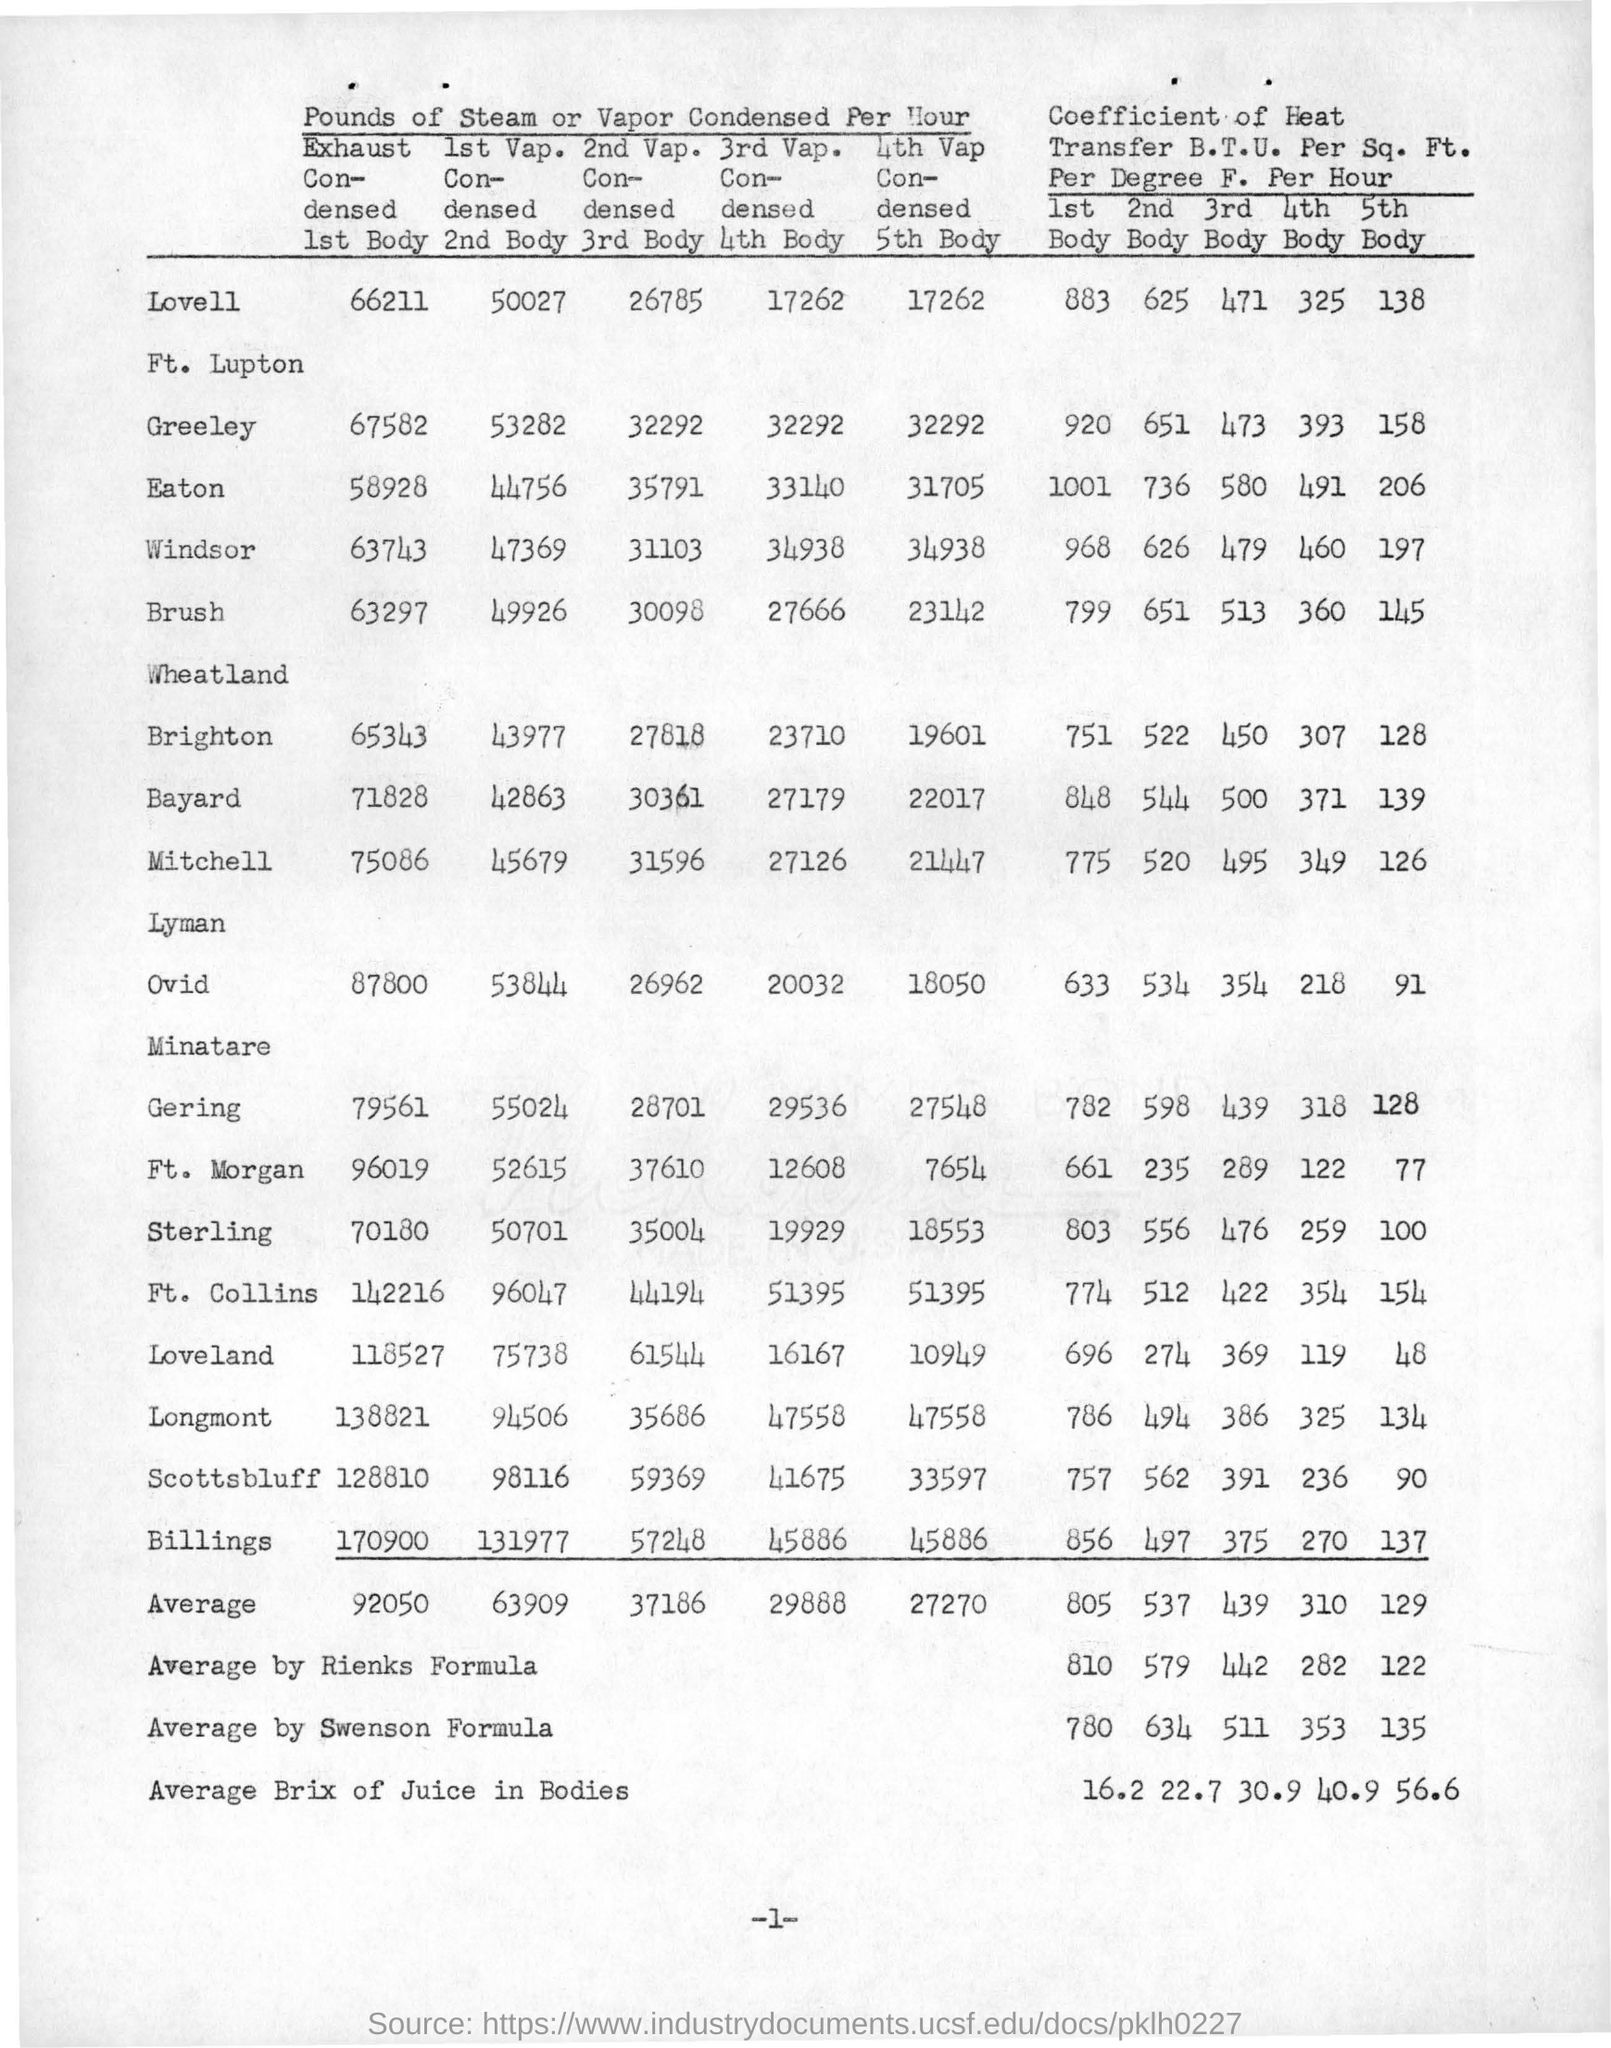Can you analyze the trend in heat transfer coefficients across the bodies shown in the table? Certainly. The table in the image shows a descending trend in the heat transfer coefficients from the 1st to the 5th body across various locations. This indicates that the first body has the highest coefficient of heat transfer, which subsequently decreases through to the fifth body. Such a trend may suggest that as steam or vapor moves through each subsequent body, its ability to transfer heat diminishes, potentially due to lower temperatures or changes in steam quality, among other factors. This could also reflect different operational roles or efficiencies inherent to each stage of the condensing process. 